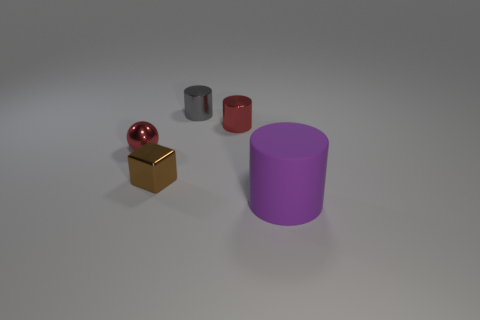The thing that is both in front of the small red shiny cylinder and on the right side of the gray cylinder is what color?
Your answer should be compact. Purple. What material is the cylinder in front of the tiny shiny thing that is in front of the thing that is to the left of the tiny brown object?
Your response must be concise. Rubber. What is the small brown object made of?
Your answer should be compact. Metal. There is a red thing that is the same shape as the small gray thing; what is its size?
Offer a very short reply. Small. Is the big rubber cylinder the same color as the cube?
Make the answer very short. No. What number of other objects are there of the same material as the block?
Offer a terse response. 3. Are there the same number of objects that are in front of the big purple cylinder and red shiny balls?
Ensure brevity in your answer.  No. There is a metallic object behind the red cylinder; is its size the same as the tiny brown metal object?
Offer a very short reply. Yes. There is a gray cylinder; what number of tiny red objects are to the left of it?
Your answer should be very brief. 1. The cylinder that is in front of the gray metal cylinder and behind the large purple cylinder is made of what material?
Keep it short and to the point. Metal. 